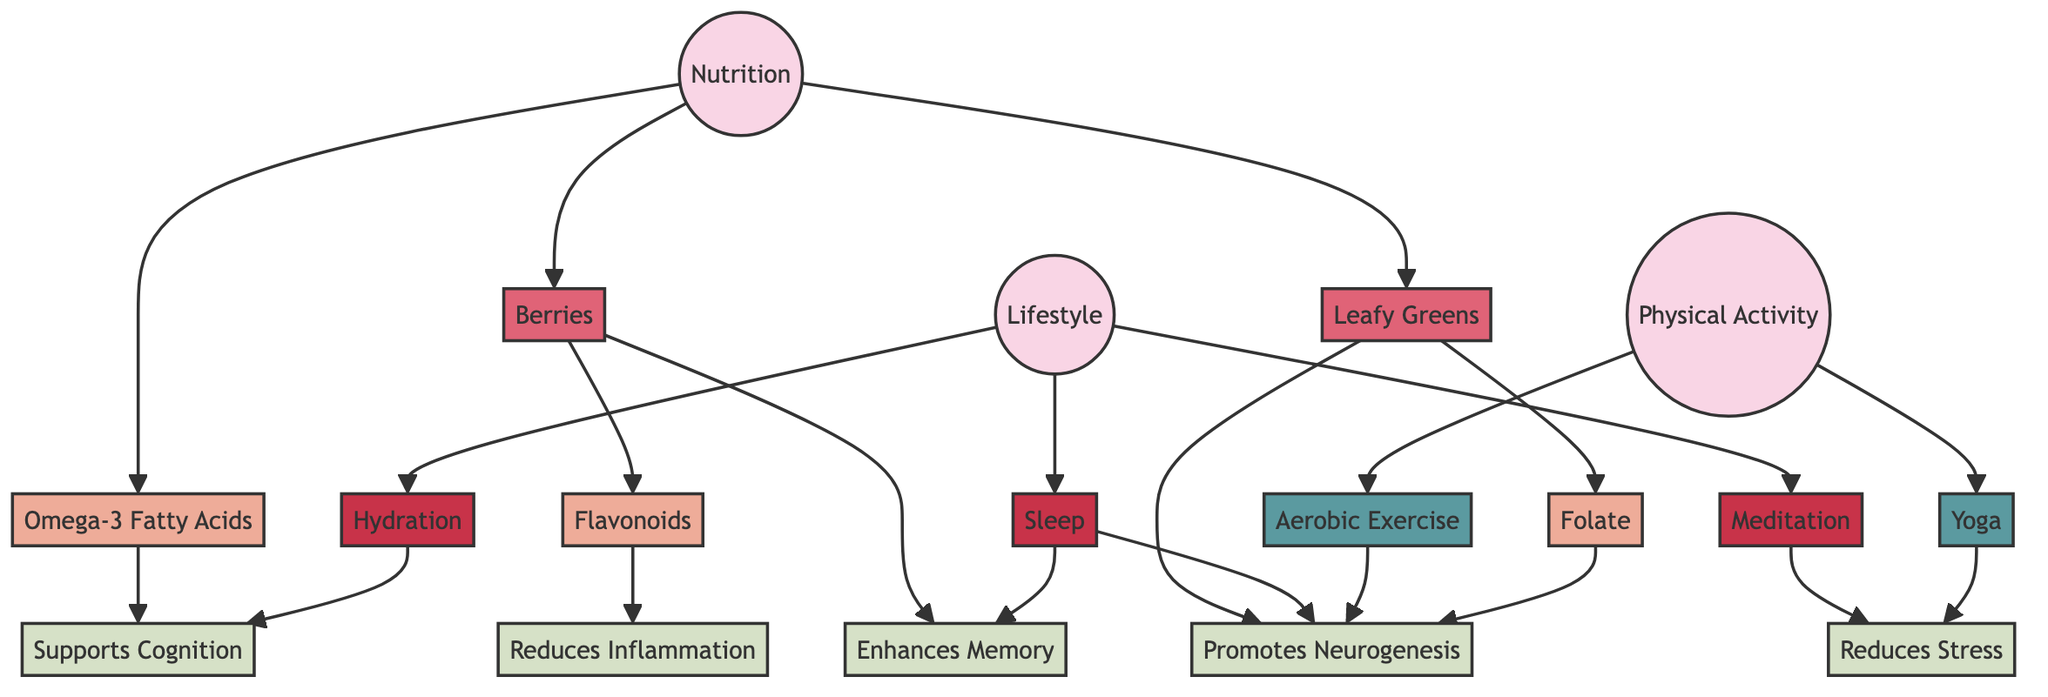What are the three categories in the diagram? The diagram contains three main categories: Nutrition, Lifestyle, and Physical Activity. These categories serve as the primary divisions in the flowchart, indicating different aspects of brain health support.
Answer: Nutrition, Lifestyle, Physical Activity How many foods are listed in the Nutrition category? The Nutrition category includes three foods: Berries, Leafy Greens, and Omega-3 Fatty Acids. Counting these foods provides the number in the Nutrition category.
Answer: 3 Which activity supports Neurogenesis? The diagram indicates two activities that support Neurogenesis: Aerobic Exercise and Yoga. By identifying the specific connections from these activities, the answer can be confirmed.
Answer: Aerobic Exercise, Yoga What lifestyle choice reduces stress? Meditation and Yoga are the lifestyle choices that contribute to reducing stress. The connections from both lifestyle choices can be followed to reach the benefit of stress reduction.
Answer: Meditation, Yoga How many benefits are linked to Leafy Greens? Leafy Greens link to two benefits: Folate and Neurogenesis. Confirming these connections provides the answer regarding how many benefits are related to Leafy Greens.
Answer: 2 Which nutrient found in Berries supports Memory Enhancement? The nutrient that links Berries to Memory Enhancement is Flavonoids. By following the connection from Berries to their associated nutrients, the answer is established.
Answer: Flavonoids What is the relationship between Sleep and Neurogenesis? Sleep is connected directly to two benefits: Memory Enhancement and Neurogenesis. This relationship shows that Sleep positively impacts both cognitive functions.
Answer: Supports Neurogenesis How many physical activities are mentioned in the diagram? The Physical Activity category features two activities: Aerobic Exercise and Yoga. Counting these activities gives the total number mentioned in the diagram.
Answer: 2 What role do Omega-3 Fatty Acids play? Omega-3 Fatty Acids support Cognition. Tracing the connection from Omega-3 Fatty Acids will clearly illustrate their role in brain health.
Answer: Supports Cognition 